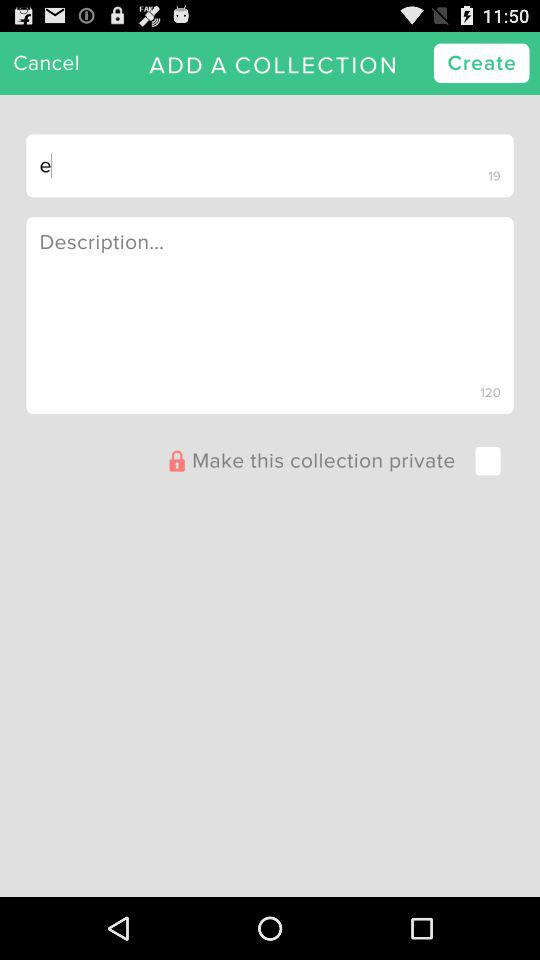What is the word limit for the description? The word limit for the description is 120. 